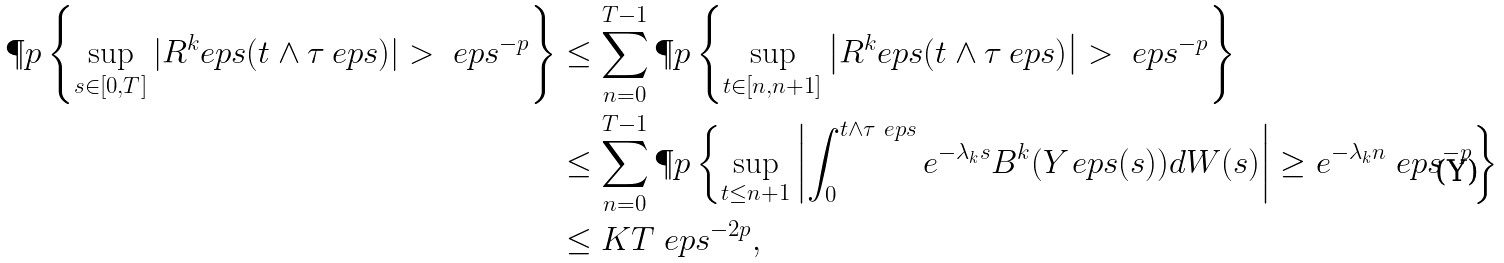<formula> <loc_0><loc_0><loc_500><loc_500>\P p \left \{ \sup _ { s \in [ 0 , T ] } | R ^ { k } _ { \ } e p s ( t \wedge \tau _ { \ } e p s ) | > \ e p s ^ { - p } \right \} & \leq \sum _ { n = 0 } ^ { T - 1 } \P p \left \{ \sup _ { t \in [ n , n + 1 ] } \left | R ^ { k } _ { \ } e p s ( t \wedge \tau _ { \ } e p s ) \right | > \ e p s ^ { - p } \right \} \\ & \leq \sum _ { n = 0 } ^ { T - 1 } \P p \left \{ \sup _ { t \leq n + 1 } \left | \int _ { 0 } ^ { t \wedge \tau _ { \ } e p s } e ^ { - \lambda _ { k } s } B ^ { k } ( Y _ { \ } e p s ( s ) ) d W ( s ) \right | \geq e ^ { - \lambda _ { k } n } \ e p s ^ { - p } \right \} \\ & \leq K T \ e p s ^ { - 2 p } ,</formula> 